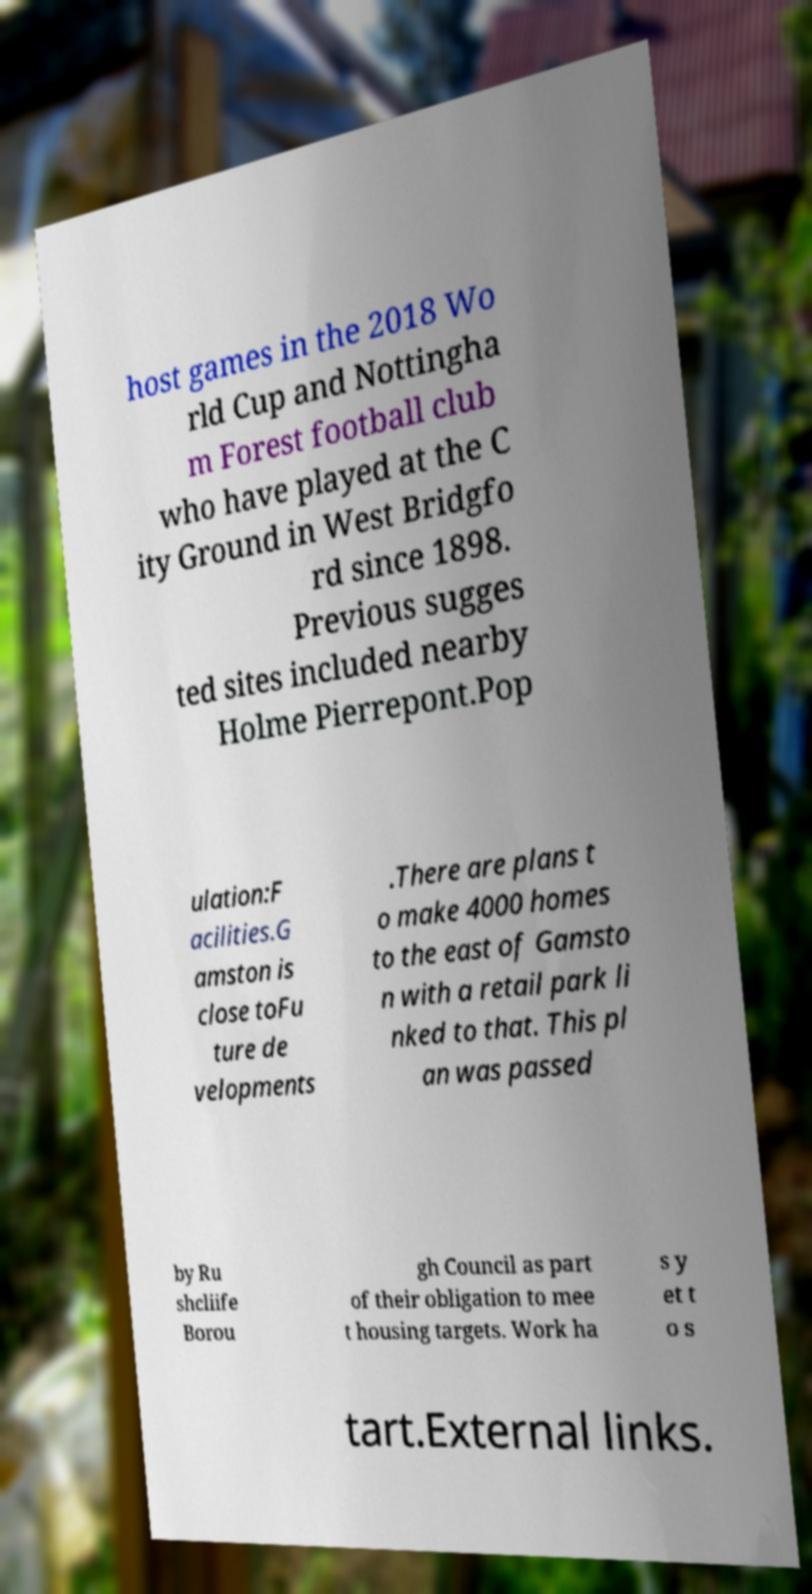Please read and relay the text visible in this image. What does it say? host games in the 2018 Wo rld Cup and Nottingha m Forest football club who have played at the C ity Ground in West Bridgfo rd since 1898. Previous sugges ted sites included nearby Holme Pierrepont.Pop ulation:F acilities.G amston is close toFu ture de velopments .There are plans t o make 4000 homes to the east of Gamsto n with a retail park li nked to that. This pl an was passed by Ru shcliife Borou gh Council as part of their obligation to mee t housing targets. Work ha s y et t o s tart.External links. 